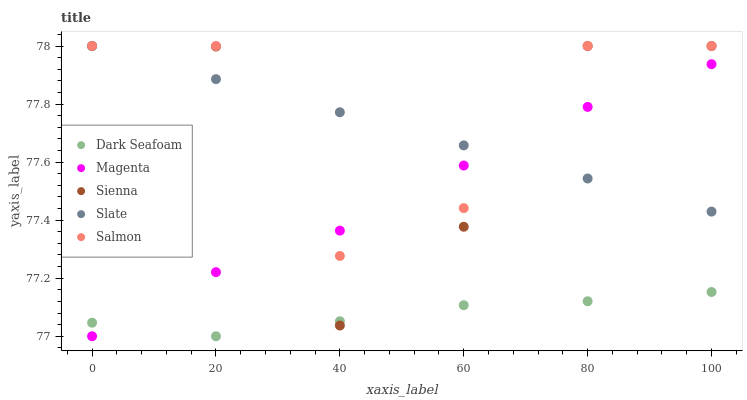Does Dark Seafoam have the minimum area under the curve?
Answer yes or no. Yes. Does Salmon have the maximum area under the curve?
Answer yes or no. Yes. Does Slate have the minimum area under the curve?
Answer yes or no. No. Does Slate have the maximum area under the curve?
Answer yes or no. No. Is Slate the smoothest?
Answer yes or no. Yes. Is Sienna the roughest?
Answer yes or no. Yes. Is Dark Seafoam the smoothest?
Answer yes or no. No. Is Dark Seafoam the roughest?
Answer yes or no. No. Does Dark Seafoam have the lowest value?
Answer yes or no. Yes. Does Slate have the lowest value?
Answer yes or no. No. Does Salmon have the highest value?
Answer yes or no. Yes. Does Dark Seafoam have the highest value?
Answer yes or no. No. Is Dark Seafoam less than Slate?
Answer yes or no. Yes. Is Slate greater than Dark Seafoam?
Answer yes or no. Yes. Does Sienna intersect Dark Seafoam?
Answer yes or no. Yes. Is Sienna less than Dark Seafoam?
Answer yes or no. No. Is Sienna greater than Dark Seafoam?
Answer yes or no. No. Does Dark Seafoam intersect Slate?
Answer yes or no. No. 